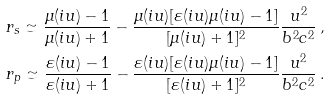<formula> <loc_0><loc_0><loc_500><loc_500>& r _ { s } \simeq \frac { \mu ( i u ) - 1 } { \mu ( i u ) + 1 } - \frac { \mu ( i u ) [ \varepsilon ( i u ) \mu ( i u ) - 1 ] } { [ \mu ( i u ) + 1 ] ^ { 2 } } \frac { u ^ { 2 } } { b ^ { 2 } c ^ { 2 } } \, , \\ & r _ { p } \simeq \frac { \varepsilon ( i u ) - 1 } { \varepsilon ( i u ) + 1 } - \frac { \varepsilon ( i u ) [ \varepsilon ( i u ) \mu ( i u ) - 1 ] } { [ \varepsilon ( i u ) + 1 ] ^ { 2 } } \frac { u ^ { 2 } } { b ^ { 2 } c ^ { 2 } } \, .</formula> 